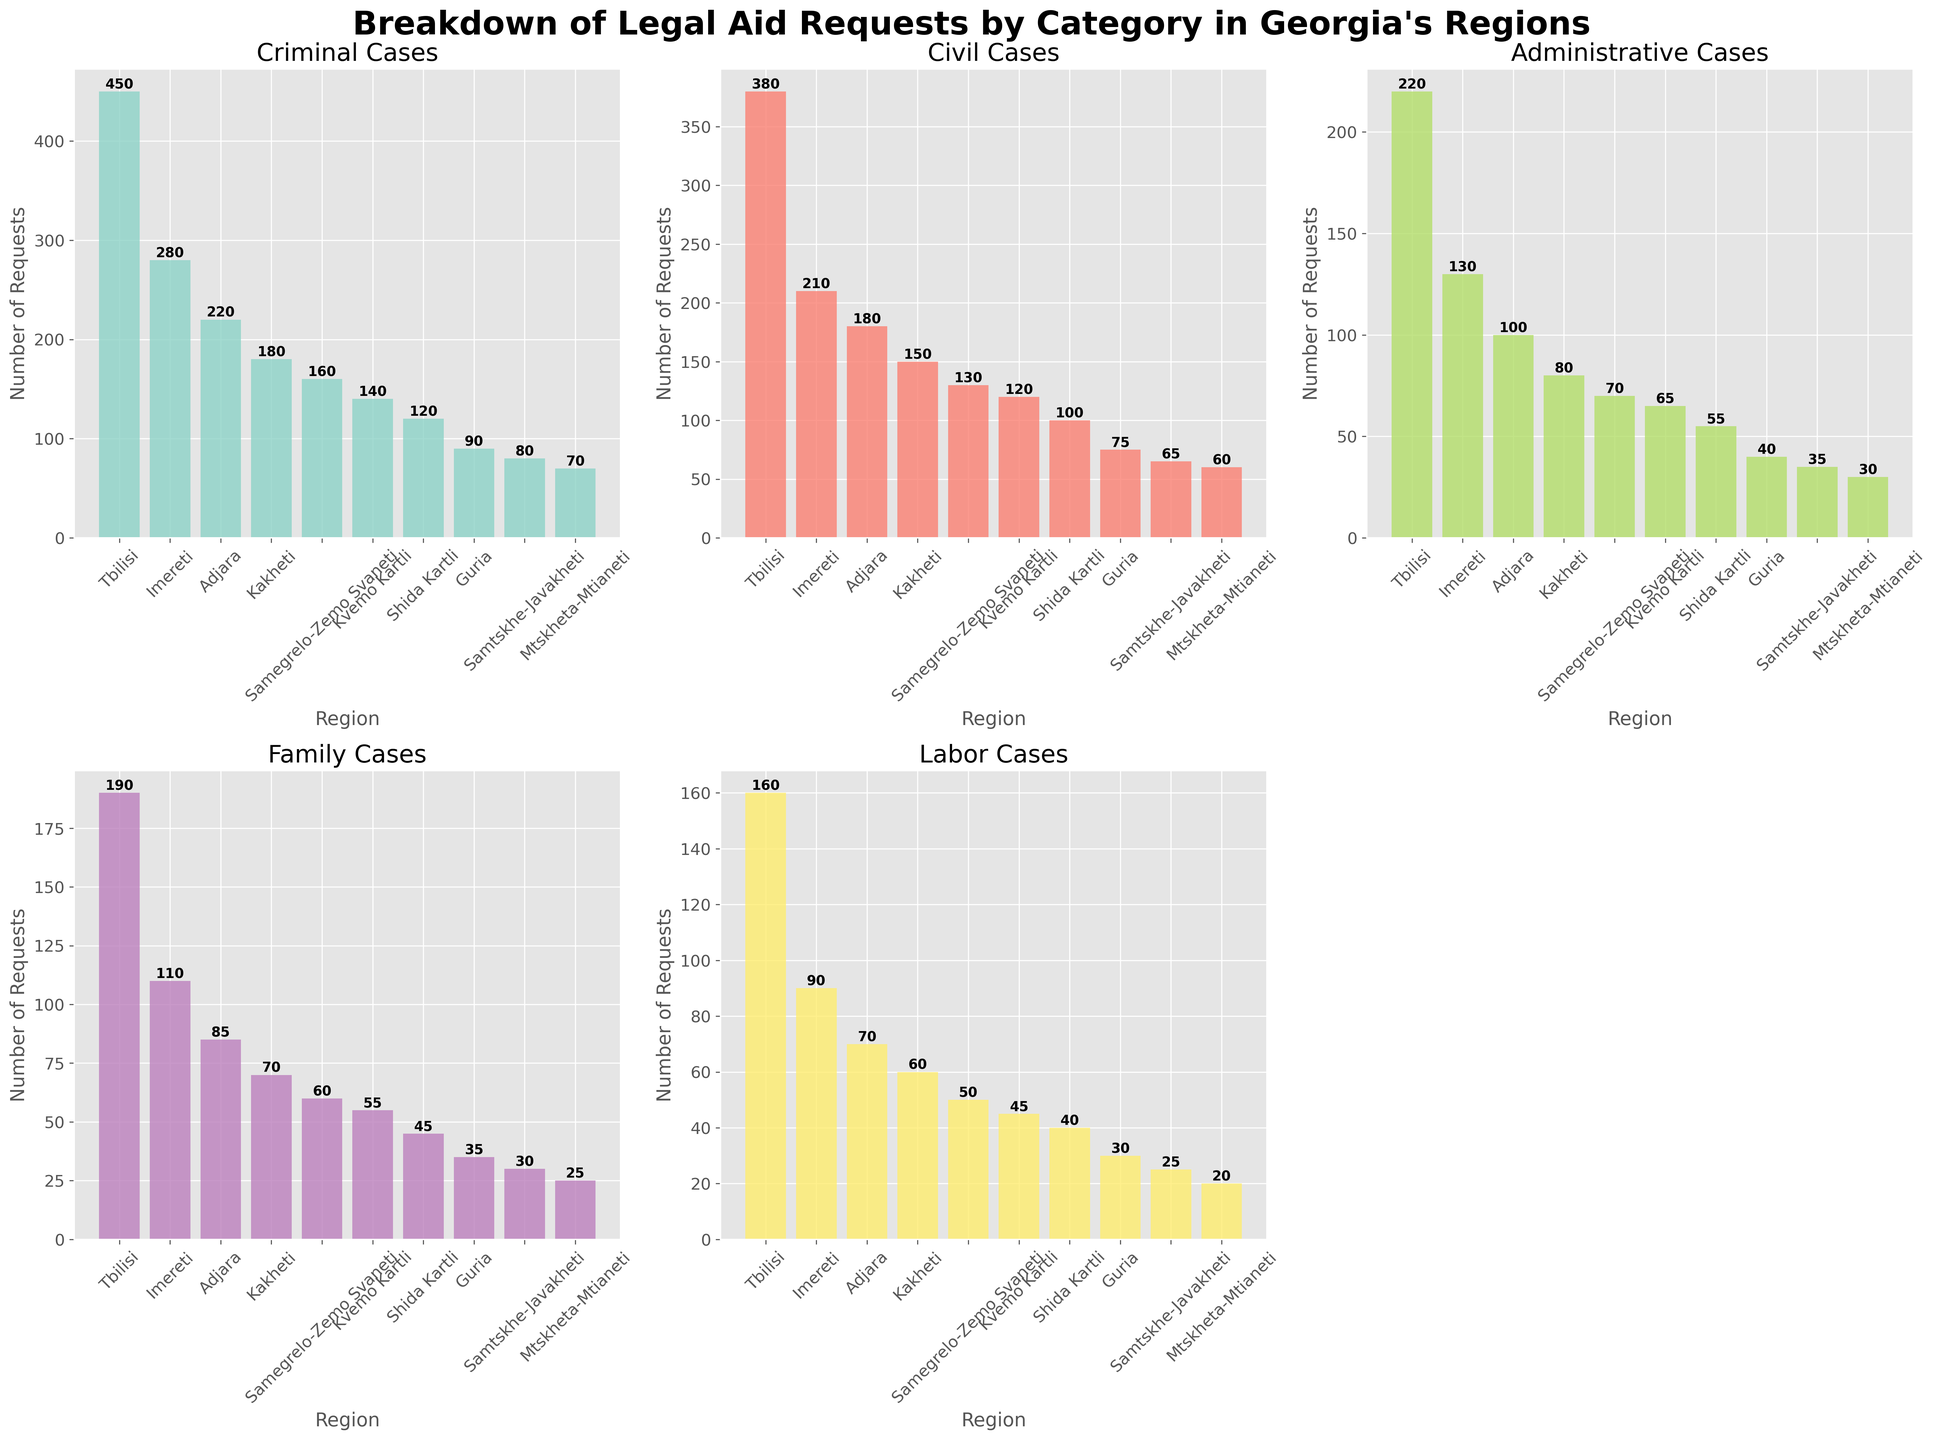What is the title of the figure? The title of the figure is prominently displayed at the top.
Answer: Breakdown of Legal Aid Requests by Category in Georgia's Regions Which region has the highest number of Criminal cases? Look at the bar representing Criminal cases for each region and find the one with the highest value.
Answer: Tbilisi What is the total number of Civil cases in Adjara and Kakheti combined? Add the values of Civil cases for Adjara and Kakheti (180 + 150).
Answer: 330 Which category has the fewest legal aid requests in Tbilisi? For Tbilisi, compare the values of all the categories and find the smallest one.
Answer: Labor How many more Criminal cases are there in Imereti compared to Shida Kartli? Subtract the Criminal cases in Shida Kartli from the Criminal cases in Imereti (280 - 120).
Answer: 160 Which region has the lowest number of Administrative cases? Look at the bar representing Administrative cases for each region and find the one with the lowest value.
Answer: Mtskheta-Mtianeti What is the average number of Family cases across all regions? Sum all the Family cases and then divide by the number of regions ((190 + 110 + 85 + 70 + 60 + 55 + 45 + 35 + 30 + 25) / 10).
Answer: 70.5 Is the total number of Labor cases in Kakheti greater than the total number of Administrative cases in Samegrelo-Zemo Svaneti? Compare the number of Labor cases in Kakheti (60) and Administrative cases in Samegrelo-Zemo Svaneti (70).
Answer: No How does the number of Civil cases in Mtskheta-Mtianeti compare to the number of Family cases in Guria? Compare the values of Civil cases in Mtskheta-Mtianeti (60) with Family cases in Guria (35).
Answer: Greater Which category of cases is not represented in the second subplot on the bottom row (axes[1, 2])? The second subplot in the bottom row was removed, indicating no category is represented there.
Answer: None 